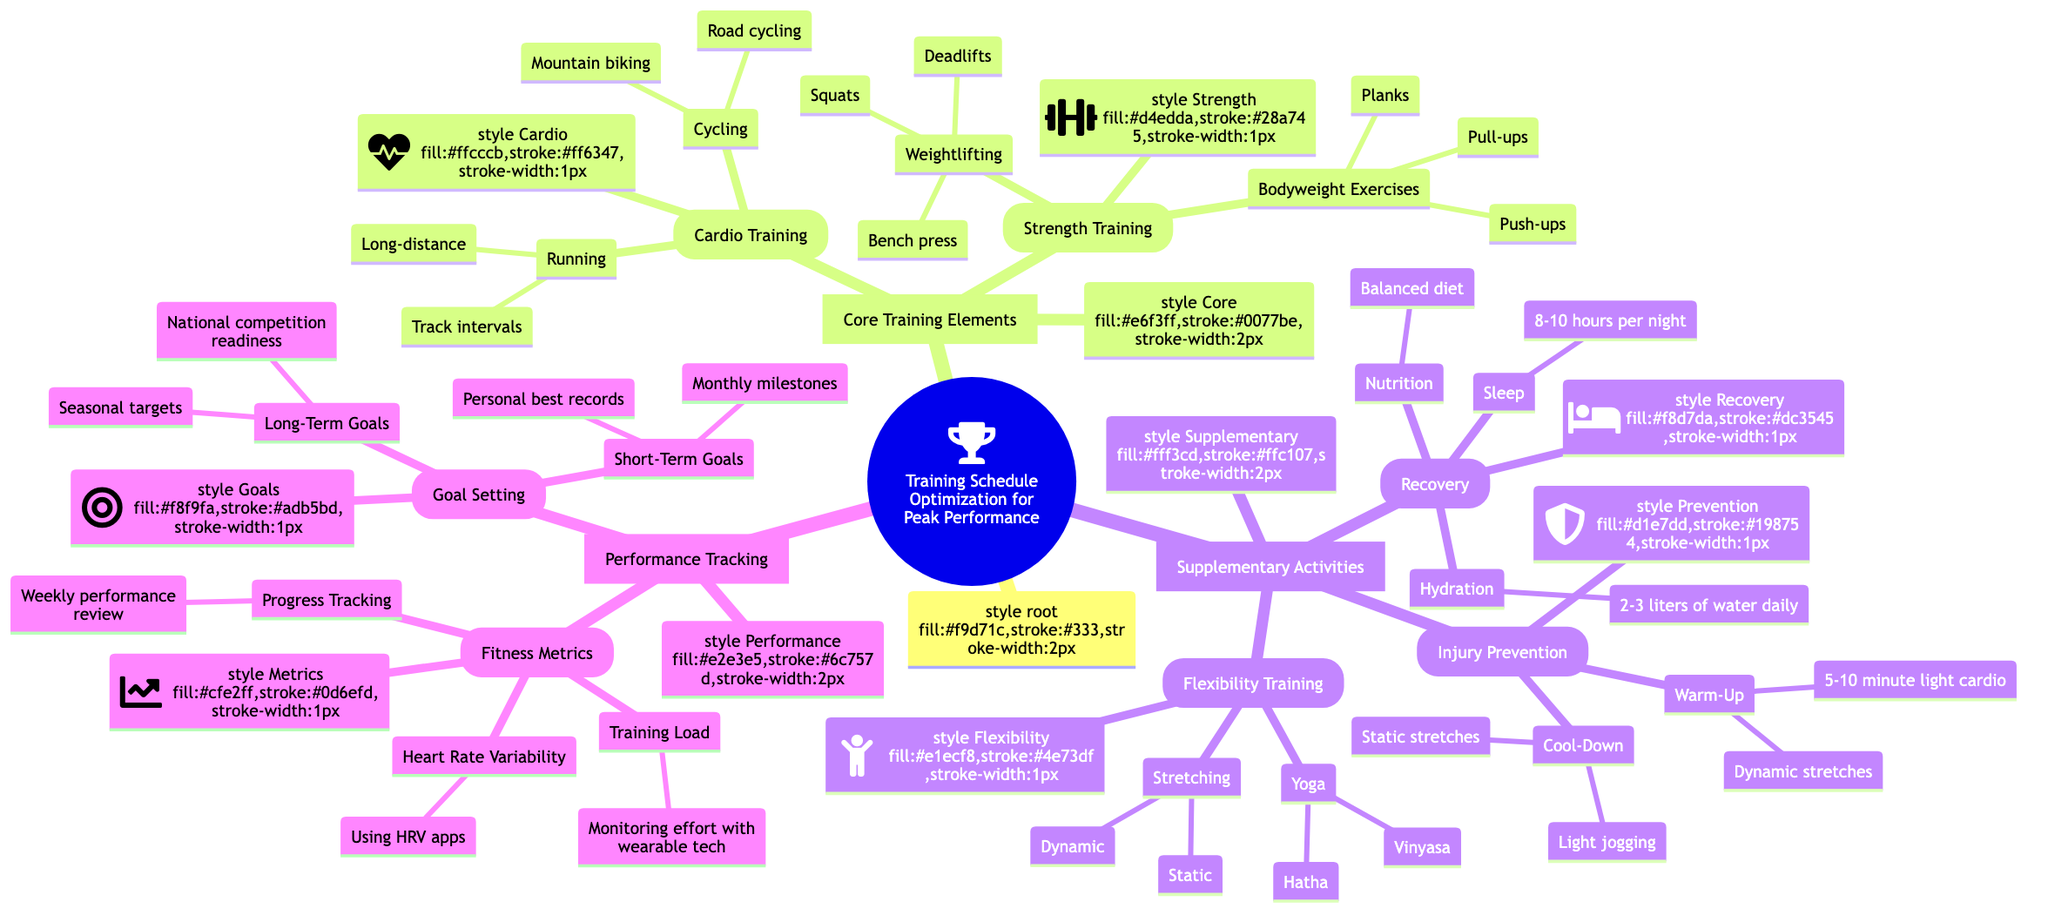What are the two main categories of the Core Training Elements? The diagram shows "Cardio Training" and "Strength Training" as the two main subcategories under "Core Training Elements".
Answer: Cardio Training, Strength Training How many types of Flexibility Training are listed? Under "Flexibility Training", there are two types: "Yoga" and "Stretching". Therefore, the count is two.
Answer: 2 What does the Recovery section advise for Sleep? The diagram states that the recommended duration for sleep in the Recovery section is "8-10 hours per night".
Answer: 8-10 hours per night Which section includes “Monitoring effort with wearable tech”? This phrase is found under "Performance Tracking" in the "Fitness Metrics" subsection.
Answer: Fitness Metrics What are the two categories of Goal Setting? The Goal Setting category is divided into "Short-Term Goals" and "Long-Term Goals".
Answer: Short-Term Goals, Long-Term Goals How many components are listed under Injury Prevention? The "Injury Prevention" section has two main components: "Warm-Up" and "Cool-Down", therefore the total count is two.
Answer: 2 Which training type includes “Dynamic stretches”? "Dynamic stretches" is included under "Injury Prevention" in the "Warm-Up" subsection.
Answer: Warm-Up What is the first component of Bodyweight Exercises? The first listed component under "Bodyweight Exercises" is "Pull-ups".
Answer: Pull-ups What is one example of cardio training listed? The diagram specifies “Track intervals” as one example within the "Cardio Training" category.
Answer: Track intervals 